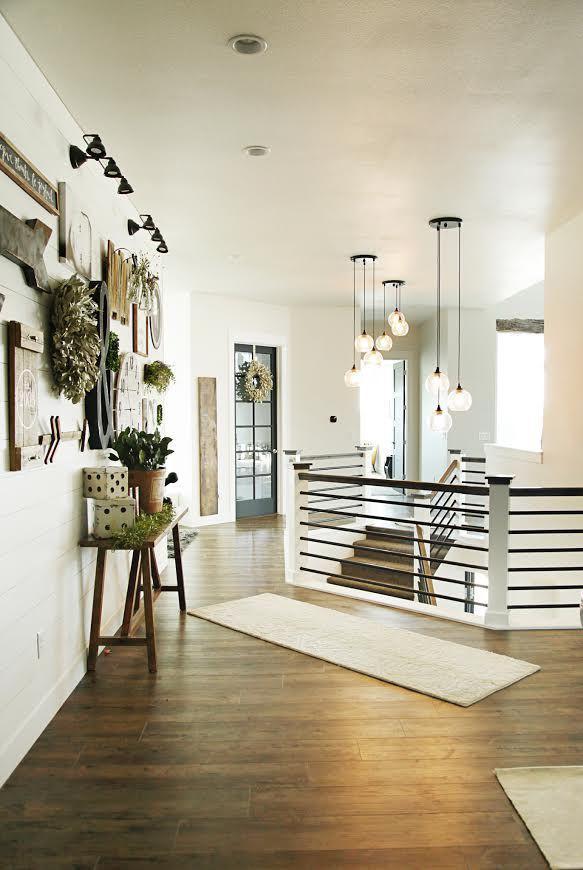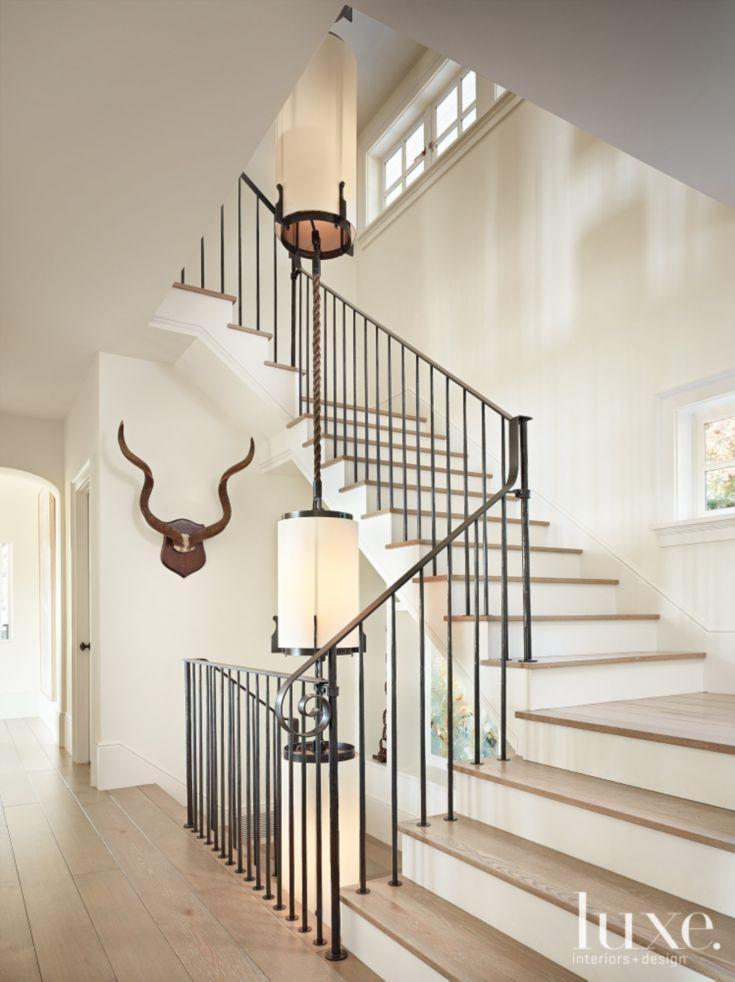The first image is the image on the left, the second image is the image on the right. Examine the images to the left and right. Is the description "The left image has visible stair steps, the right image does not." accurate? Answer yes or no. No. The first image is the image on the left, the second image is the image on the right. Considering the images on both sides, is "The right image is taken from downstairs." valid? Answer yes or no. Yes. 